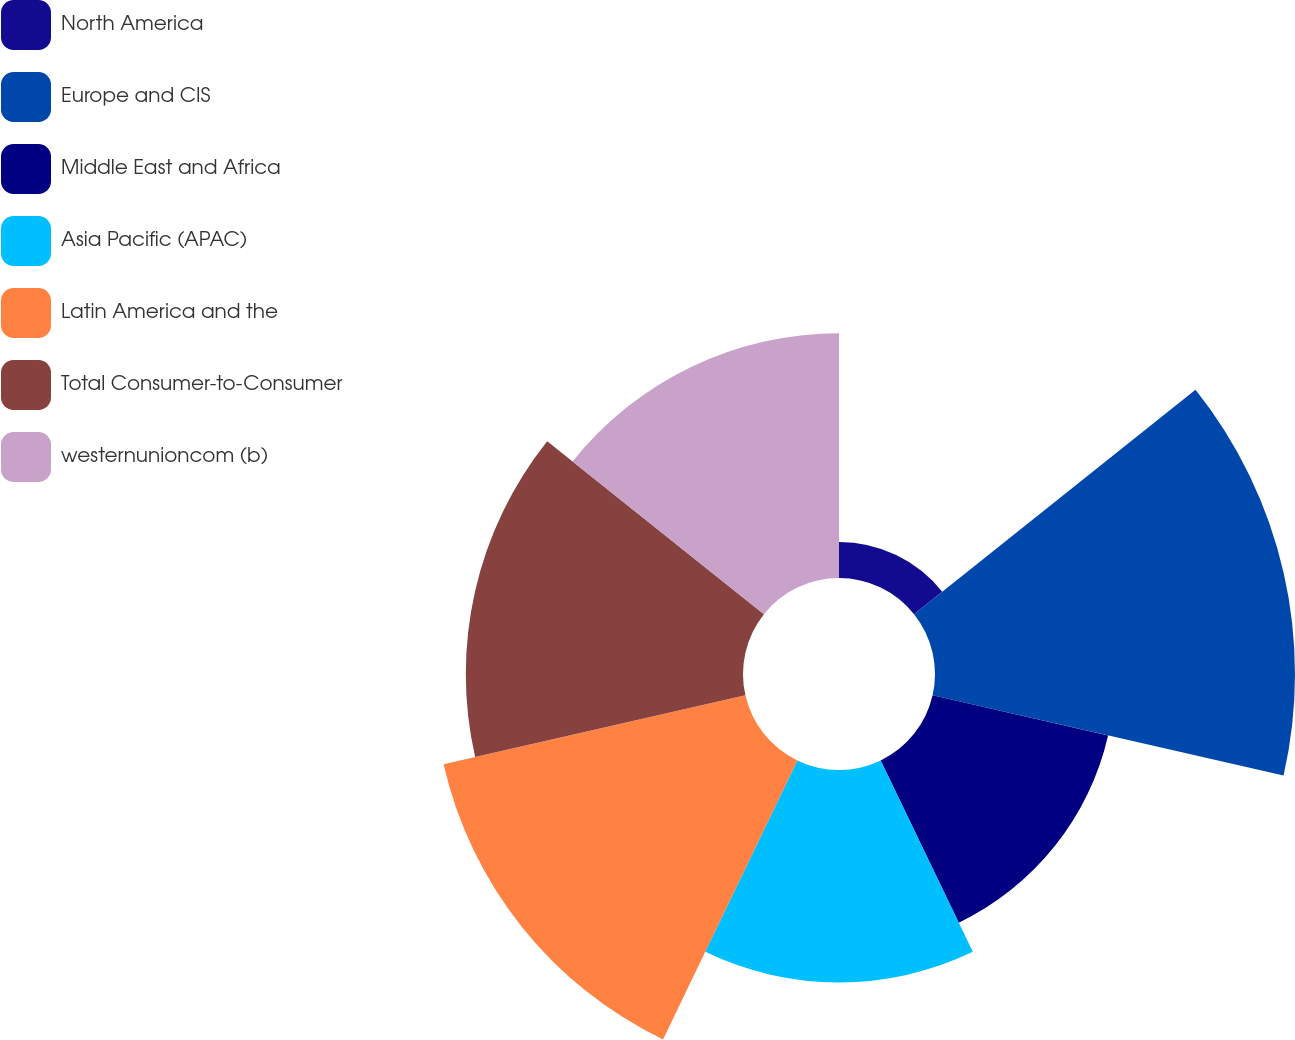Convert chart to OTSL. <chart><loc_0><loc_0><loc_500><loc_500><pie_chart><fcel>North America<fcel>Europe and CIS<fcel>Middle East and Africa<fcel>Asia Pacific (APAC)<fcel>Latin America and the<fcel>Total Consumer-to-Consumer<fcel>westernunioncom (b)<nl><fcel>2.22%<fcel>22.22%<fcel>11.11%<fcel>13.11%<fcel>19.11%<fcel>17.11%<fcel>15.11%<nl></chart> 